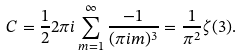<formula> <loc_0><loc_0><loc_500><loc_500>C = \frac { 1 } { 2 } 2 \pi i \sum _ { m = 1 } ^ { \infty } \frac { - 1 } { ( \pi i m ) ^ { 3 } } = \frac { 1 } { \pi ^ { 2 } } \zeta ( 3 ) .</formula> 